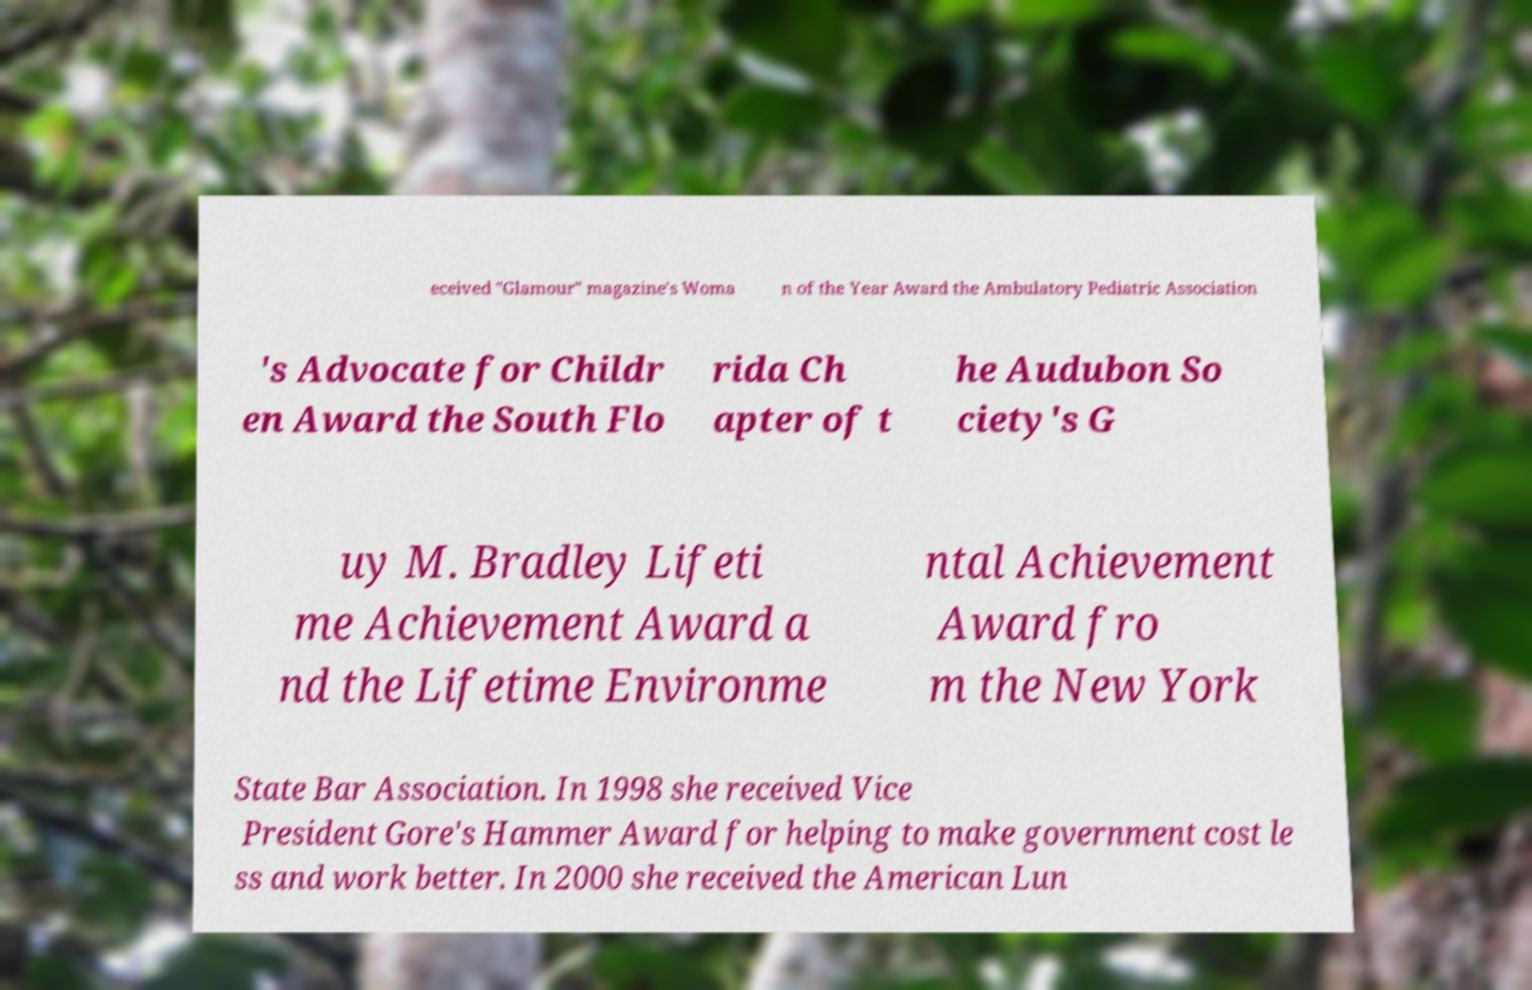There's text embedded in this image that I need extracted. Can you transcribe it verbatim? eceived "Glamour" magazine's Woma n of the Year Award the Ambulatory Pediatric Association 's Advocate for Childr en Award the South Flo rida Ch apter of t he Audubon So ciety's G uy M. Bradley Lifeti me Achievement Award a nd the Lifetime Environme ntal Achievement Award fro m the New York State Bar Association. In 1998 she received Vice President Gore's Hammer Award for helping to make government cost le ss and work better. In 2000 she received the American Lun 